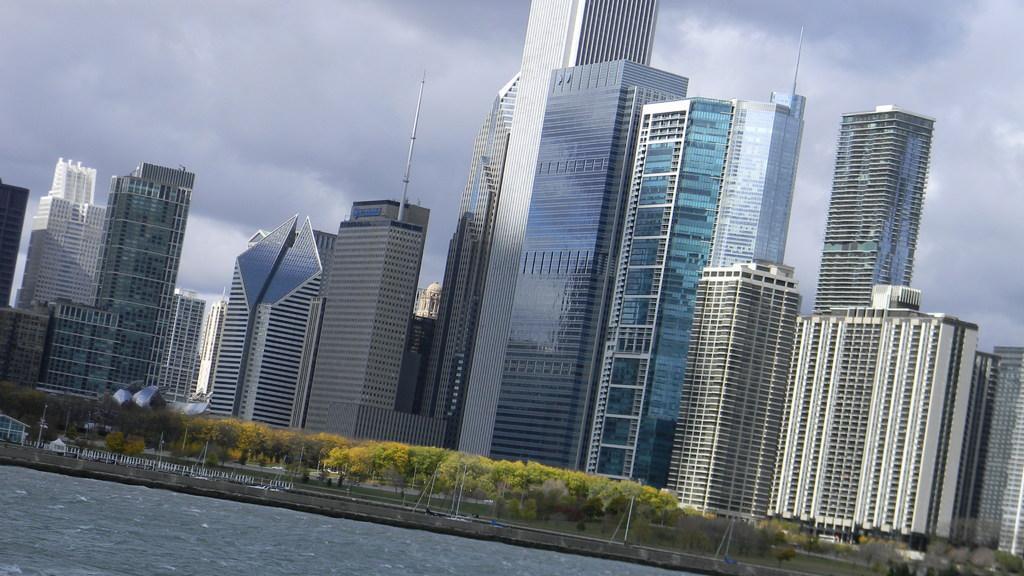Please provide a concise description of this image. In the picture I can see buildings, trees, poles, the water and some other objects. In the background I can see the sky. 